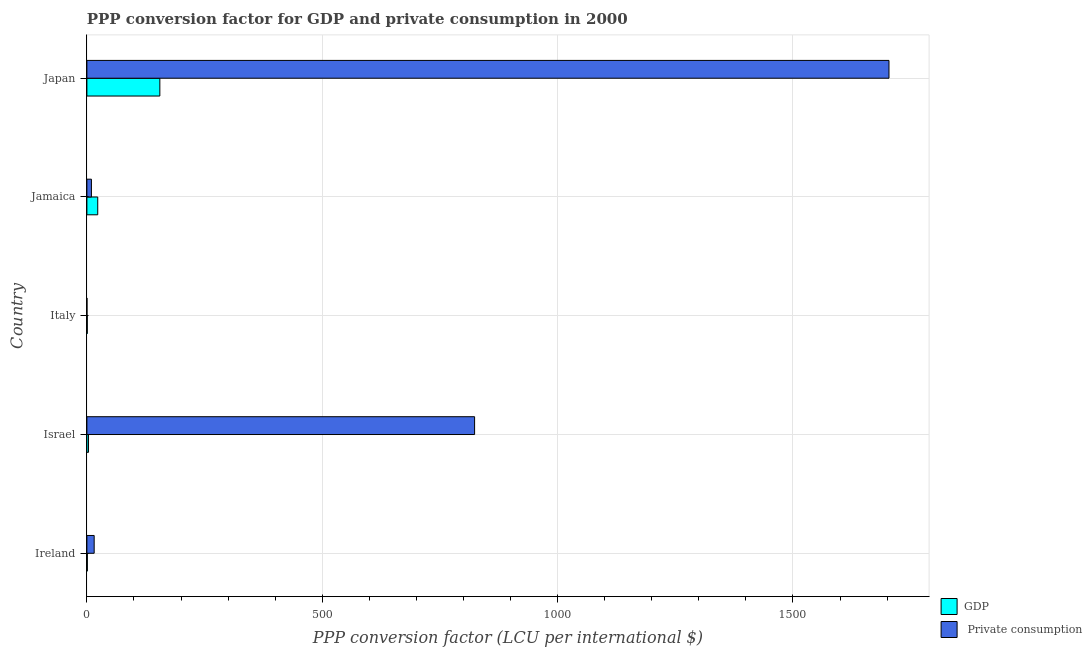How many groups of bars are there?
Offer a very short reply. 5. How many bars are there on the 5th tick from the top?
Give a very brief answer. 2. What is the label of the 3rd group of bars from the top?
Offer a very short reply. Italy. In how many cases, is the number of bars for a given country not equal to the number of legend labels?
Make the answer very short. 0. What is the ppp conversion factor for gdp in Israel?
Make the answer very short. 3.45. Across all countries, what is the maximum ppp conversion factor for private consumption?
Provide a short and direct response. 1703.99. Across all countries, what is the minimum ppp conversion factor for private consumption?
Your answer should be very brief. 0.16. In which country was the ppp conversion factor for private consumption maximum?
Your answer should be very brief. Japan. What is the total ppp conversion factor for gdp in the graph?
Your answer should be compact. 183.24. What is the difference between the ppp conversion factor for gdp in Israel and that in Jamaica?
Keep it short and to the point. -19.59. What is the difference between the ppp conversion factor for private consumption in Japan and the ppp conversion factor for gdp in Italy?
Offer a very short reply. 1703.17. What is the average ppp conversion factor for gdp per country?
Provide a short and direct response. 36.65. What is the difference between the ppp conversion factor for private consumption and ppp conversion factor for gdp in Jamaica?
Your response must be concise. -13.41. In how many countries, is the ppp conversion factor for gdp greater than 1600 LCU?
Ensure brevity in your answer.  0. What is the ratio of the ppp conversion factor for private consumption in Jamaica to that in Japan?
Ensure brevity in your answer.  0.01. What is the difference between the highest and the second highest ppp conversion factor for gdp?
Provide a succinct answer. 131.93. What is the difference between the highest and the lowest ppp conversion factor for private consumption?
Provide a succinct answer. 1703.83. What does the 2nd bar from the top in Israel represents?
Provide a short and direct response. GDP. What does the 1st bar from the bottom in Jamaica represents?
Offer a very short reply. GDP. How many bars are there?
Ensure brevity in your answer.  10. Are all the bars in the graph horizontal?
Make the answer very short. Yes. What is the difference between two consecutive major ticks on the X-axis?
Offer a very short reply. 500. Are the values on the major ticks of X-axis written in scientific E-notation?
Give a very brief answer. No. Does the graph contain any zero values?
Provide a short and direct response. No. Does the graph contain grids?
Your answer should be compact. Yes. What is the title of the graph?
Offer a very short reply. PPP conversion factor for GDP and private consumption in 2000. Does "Personal remittances" appear as one of the legend labels in the graph?
Your response must be concise. No. What is the label or title of the X-axis?
Give a very brief answer. PPP conversion factor (LCU per international $). What is the label or title of the Y-axis?
Your answer should be compact. Country. What is the PPP conversion factor (LCU per international $) of GDP in Ireland?
Keep it short and to the point. 0.96. What is the PPP conversion factor (LCU per international $) in  Private consumption in Ireland?
Give a very brief answer. 15.46. What is the PPP conversion factor (LCU per international $) in GDP in Israel?
Provide a short and direct response. 3.45. What is the PPP conversion factor (LCU per international $) in  Private consumption in Israel?
Provide a succinct answer. 823.64. What is the PPP conversion factor (LCU per international $) of GDP in Italy?
Make the answer very short. 0.82. What is the PPP conversion factor (LCU per international $) in  Private consumption in Italy?
Your response must be concise. 0.16. What is the PPP conversion factor (LCU per international $) of GDP in Jamaica?
Your response must be concise. 23.04. What is the PPP conversion factor (LCU per international $) of  Private consumption in Jamaica?
Provide a succinct answer. 9.63. What is the PPP conversion factor (LCU per international $) of GDP in Japan?
Your answer should be compact. 154.97. What is the PPP conversion factor (LCU per international $) in  Private consumption in Japan?
Provide a succinct answer. 1703.99. Across all countries, what is the maximum PPP conversion factor (LCU per international $) in GDP?
Your response must be concise. 154.97. Across all countries, what is the maximum PPP conversion factor (LCU per international $) of  Private consumption?
Give a very brief answer. 1703.99. Across all countries, what is the minimum PPP conversion factor (LCU per international $) in GDP?
Provide a succinct answer. 0.82. Across all countries, what is the minimum PPP conversion factor (LCU per international $) in  Private consumption?
Provide a succinct answer. 0.16. What is the total PPP conversion factor (LCU per international $) of GDP in the graph?
Make the answer very short. 183.24. What is the total PPP conversion factor (LCU per international $) in  Private consumption in the graph?
Make the answer very short. 2552.88. What is the difference between the PPP conversion factor (LCU per international $) of GDP in Ireland and that in Israel?
Offer a terse response. -2.49. What is the difference between the PPP conversion factor (LCU per international $) in  Private consumption in Ireland and that in Israel?
Make the answer very short. -808.18. What is the difference between the PPP conversion factor (LCU per international $) of GDP in Ireland and that in Italy?
Your answer should be compact. 0.14. What is the difference between the PPP conversion factor (LCU per international $) of  Private consumption in Ireland and that in Italy?
Your answer should be compact. 15.3. What is the difference between the PPP conversion factor (LCU per international $) in GDP in Ireland and that in Jamaica?
Offer a very short reply. -22.08. What is the difference between the PPP conversion factor (LCU per international $) in  Private consumption in Ireland and that in Jamaica?
Keep it short and to the point. 5.83. What is the difference between the PPP conversion factor (LCU per international $) in GDP in Ireland and that in Japan?
Offer a very short reply. -154.01. What is the difference between the PPP conversion factor (LCU per international $) of  Private consumption in Ireland and that in Japan?
Offer a very short reply. -1688.53. What is the difference between the PPP conversion factor (LCU per international $) in GDP in Israel and that in Italy?
Ensure brevity in your answer.  2.63. What is the difference between the PPP conversion factor (LCU per international $) in  Private consumption in Israel and that in Italy?
Ensure brevity in your answer.  823.49. What is the difference between the PPP conversion factor (LCU per international $) in GDP in Israel and that in Jamaica?
Ensure brevity in your answer.  -19.59. What is the difference between the PPP conversion factor (LCU per international $) in  Private consumption in Israel and that in Jamaica?
Make the answer very short. 814.01. What is the difference between the PPP conversion factor (LCU per international $) in GDP in Israel and that in Japan?
Your response must be concise. -151.52. What is the difference between the PPP conversion factor (LCU per international $) in  Private consumption in Israel and that in Japan?
Give a very brief answer. -880.35. What is the difference between the PPP conversion factor (LCU per international $) of GDP in Italy and that in Jamaica?
Your answer should be compact. -22.23. What is the difference between the PPP conversion factor (LCU per international $) in  Private consumption in Italy and that in Jamaica?
Your answer should be compact. -9.47. What is the difference between the PPP conversion factor (LCU per international $) in GDP in Italy and that in Japan?
Your answer should be compact. -154.15. What is the difference between the PPP conversion factor (LCU per international $) of  Private consumption in Italy and that in Japan?
Provide a succinct answer. -1703.83. What is the difference between the PPP conversion factor (LCU per international $) of GDP in Jamaica and that in Japan?
Offer a terse response. -131.93. What is the difference between the PPP conversion factor (LCU per international $) in  Private consumption in Jamaica and that in Japan?
Ensure brevity in your answer.  -1694.36. What is the difference between the PPP conversion factor (LCU per international $) of GDP in Ireland and the PPP conversion factor (LCU per international $) of  Private consumption in Israel?
Provide a succinct answer. -822.68. What is the difference between the PPP conversion factor (LCU per international $) in GDP in Ireland and the PPP conversion factor (LCU per international $) in  Private consumption in Italy?
Offer a very short reply. 0.8. What is the difference between the PPP conversion factor (LCU per international $) in GDP in Ireland and the PPP conversion factor (LCU per international $) in  Private consumption in Jamaica?
Make the answer very short. -8.67. What is the difference between the PPP conversion factor (LCU per international $) in GDP in Ireland and the PPP conversion factor (LCU per international $) in  Private consumption in Japan?
Make the answer very short. -1703.03. What is the difference between the PPP conversion factor (LCU per international $) of GDP in Israel and the PPP conversion factor (LCU per international $) of  Private consumption in Italy?
Make the answer very short. 3.29. What is the difference between the PPP conversion factor (LCU per international $) in GDP in Israel and the PPP conversion factor (LCU per international $) in  Private consumption in Jamaica?
Provide a short and direct response. -6.18. What is the difference between the PPP conversion factor (LCU per international $) in GDP in Israel and the PPP conversion factor (LCU per international $) in  Private consumption in Japan?
Provide a succinct answer. -1700.54. What is the difference between the PPP conversion factor (LCU per international $) of GDP in Italy and the PPP conversion factor (LCU per international $) of  Private consumption in Jamaica?
Ensure brevity in your answer.  -8.81. What is the difference between the PPP conversion factor (LCU per international $) of GDP in Italy and the PPP conversion factor (LCU per international $) of  Private consumption in Japan?
Provide a short and direct response. -1703.17. What is the difference between the PPP conversion factor (LCU per international $) of GDP in Jamaica and the PPP conversion factor (LCU per international $) of  Private consumption in Japan?
Ensure brevity in your answer.  -1680.95. What is the average PPP conversion factor (LCU per international $) in GDP per country?
Your answer should be compact. 36.65. What is the average PPP conversion factor (LCU per international $) in  Private consumption per country?
Keep it short and to the point. 510.58. What is the difference between the PPP conversion factor (LCU per international $) of GDP and PPP conversion factor (LCU per international $) of  Private consumption in Ireland?
Ensure brevity in your answer.  -14.5. What is the difference between the PPP conversion factor (LCU per international $) in GDP and PPP conversion factor (LCU per international $) in  Private consumption in Israel?
Offer a very short reply. -820.19. What is the difference between the PPP conversion factor (LCU per international $) of GDP and PPP conversion factor (LCU per international $) of  Private consumption in Italy?
Keep it short and to the point. 0.66. What is the difference between the PPP conversion factor (LCU per international $) in GDP and PPP conversion factor (LCU per international $) in  Private consumption in Jamaica?
Your response must be concise. 13.41. What is the difference between the PPP conversion factor (LCU per international $) in GDP and PPP conversion factor (LCU per international $) in  Private consumption in Japan?
Keep it short and to the point. -1549.02. What is the ratio of the PPP conversion factor (LCU per international $) of GDP in Ireland to that in Israel?
Provide a short and direct response. 0.28. What is the ratio of the PPP conversion factor (LCU per international $) in  Private consumption in Ireland to that in Israel?
Make the answer very short. 0.02. What is the ratio of the PPP conversion factor (LCU per international $) of GDP in Ireland to that in Italy?
Make the answer very short. 1.18. What is the ratio of the PPP conversion factor (LCU per international $) of  Private consumption in Ireland to that in Italy?
Provide a succinct answer. 98.38. What is the ratio of the PPP conversion factor (LCU per international $) of GDP in Ireland to that in Jamaica?
Give a very brief answer. 0.04. What is the ratio of the PPP conversion factor (LCU per international $) of  Private consumption in Ireland to that in Jamaica?
Ensure brevity in your answer.  1.61. What is the ratio of the PPP conversion factor (LCU per international $) of GDP in Ireland to that in Japan?
Offer a very short reply. 0.01. What is the ratio of the PPP conversion factor (LCU per international $) in  Private consumption in Ireland to that in Japan?
Offer a terse response. 0.01. What is the ratio of the PPP conversion factor (LCU per international $) in GDP in Israel to that in Italy?
Provide a short and direct response. 4.22. What is the ratio of the PPP conversion factor (LCU per international $) of  Private consumption in Israel to that in Italy?
Provide a short and direct response. 5241.2. What is the ratio of the PPP conversion factor (LCU per international $) of GDP in Israel to that in Jamaica?
Offer a very short reply. 0.15. What is the ratio of the PPP conversion factor (LCU per international $) in  Private consumption in Israel to that in Jamaica?
Keep it short and to the point. 85.53. What is the ratio of the PPP conversion factor (LCU per international $) in GDP in Israel to that in Japan?
Make the answer very short. 0.02. What is the ratio of the PPP conversion factor (LCU per international $) of  Private consumption in Israel to that in Japan?
Give a very brief answer. 0.48. What is the ratio of the PPP conversion factor (LCU per international $) in GDP in Italy to that in Jamaica?
Keep it short and to the point. 0.04. What is the ratio of the PPP conversion factor (LCU per international $) in  Private consumption in Italy to that in Jamaica?
Give a very brief answer. 0.02. What is the ratio of the PPP conversion factor (LCU per international $) of GDP in Italy to that in Japan?
Ensure brevity in your answer.  0.01. What is the ratio of the PPP conversion factor (LCU per international $) of  Private consumption in Italy to that in Japan?
Keep it short and to the point. 0. What is the ratio of the PPP conversion factor (LCU per international $) in GDP in Jamaica to that in Japan?
Give a very brief answer. 0.15. What is the ratio of the PPP conversion factor (LCU per international $) of  Private consumption in Jamaica to that in Japan?
Offer a very short reply. 0.01. What is the difference between the highest and the second highest PPP conversion factor (LCU per international $) of GDP?
Your answer should be compact. 131.93. What is the difference between the highest and the second highest PPP conversion factor (LCU per international $) in  Private consumption?
Offer a very short reply. 880.35. What is the difference between the highest and the lowest PPP conversion factor (LCU per international $) of GDP?
Make the answer very short. 154.15. What is the difference between the highest and the lowest PPP conversion factor (LCU per international $) of  Private consumption?
Your response must be concise. 1703.83. 